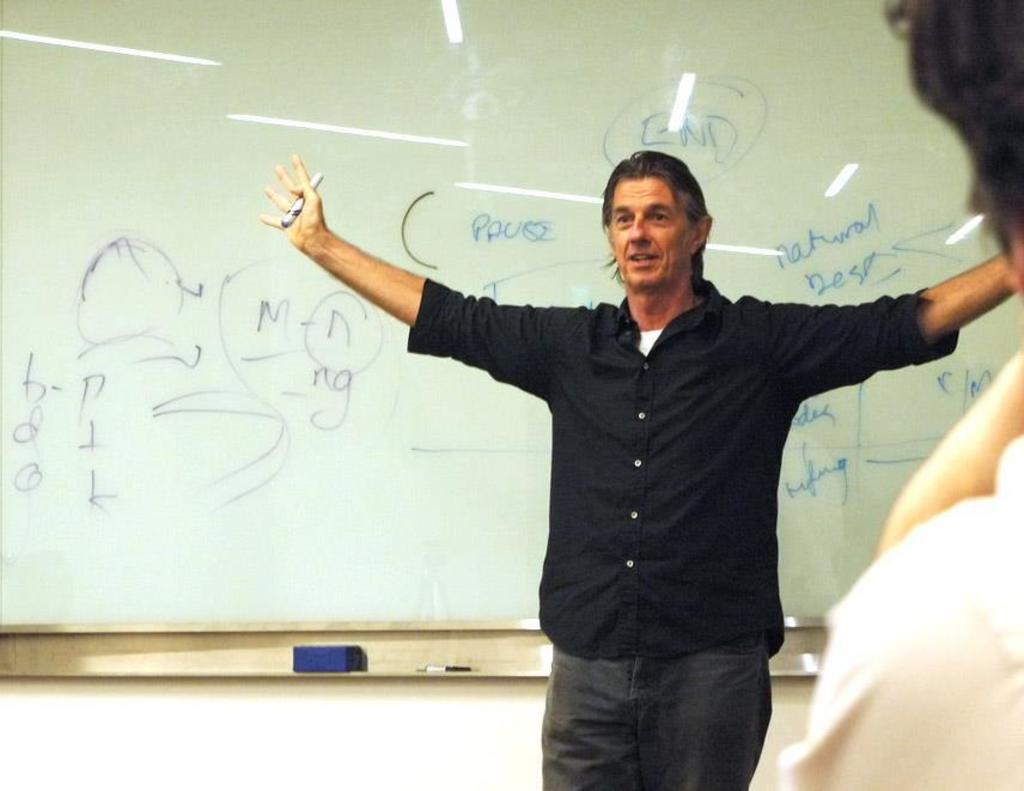<image>
Relay a brief, clear account of the picture shown. a man standing in front of a school white board with the word END above his head 